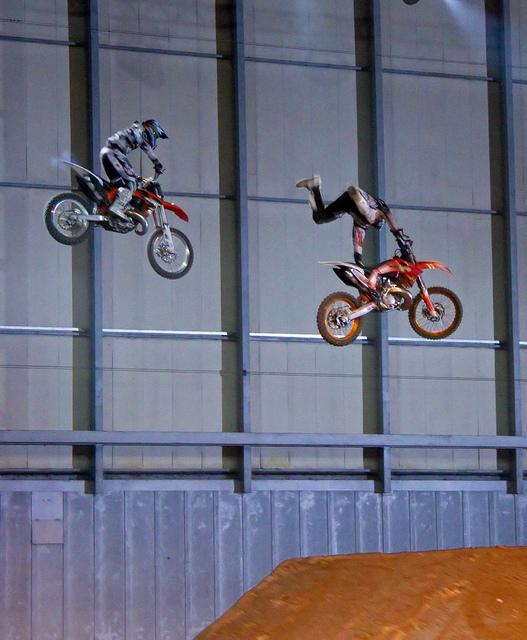Are the bikes in the air?
Concise answer only. Yes. How many bikes are there?
Answer briefly. 2. Are these bikes Harleys?
Be succinct. No. 